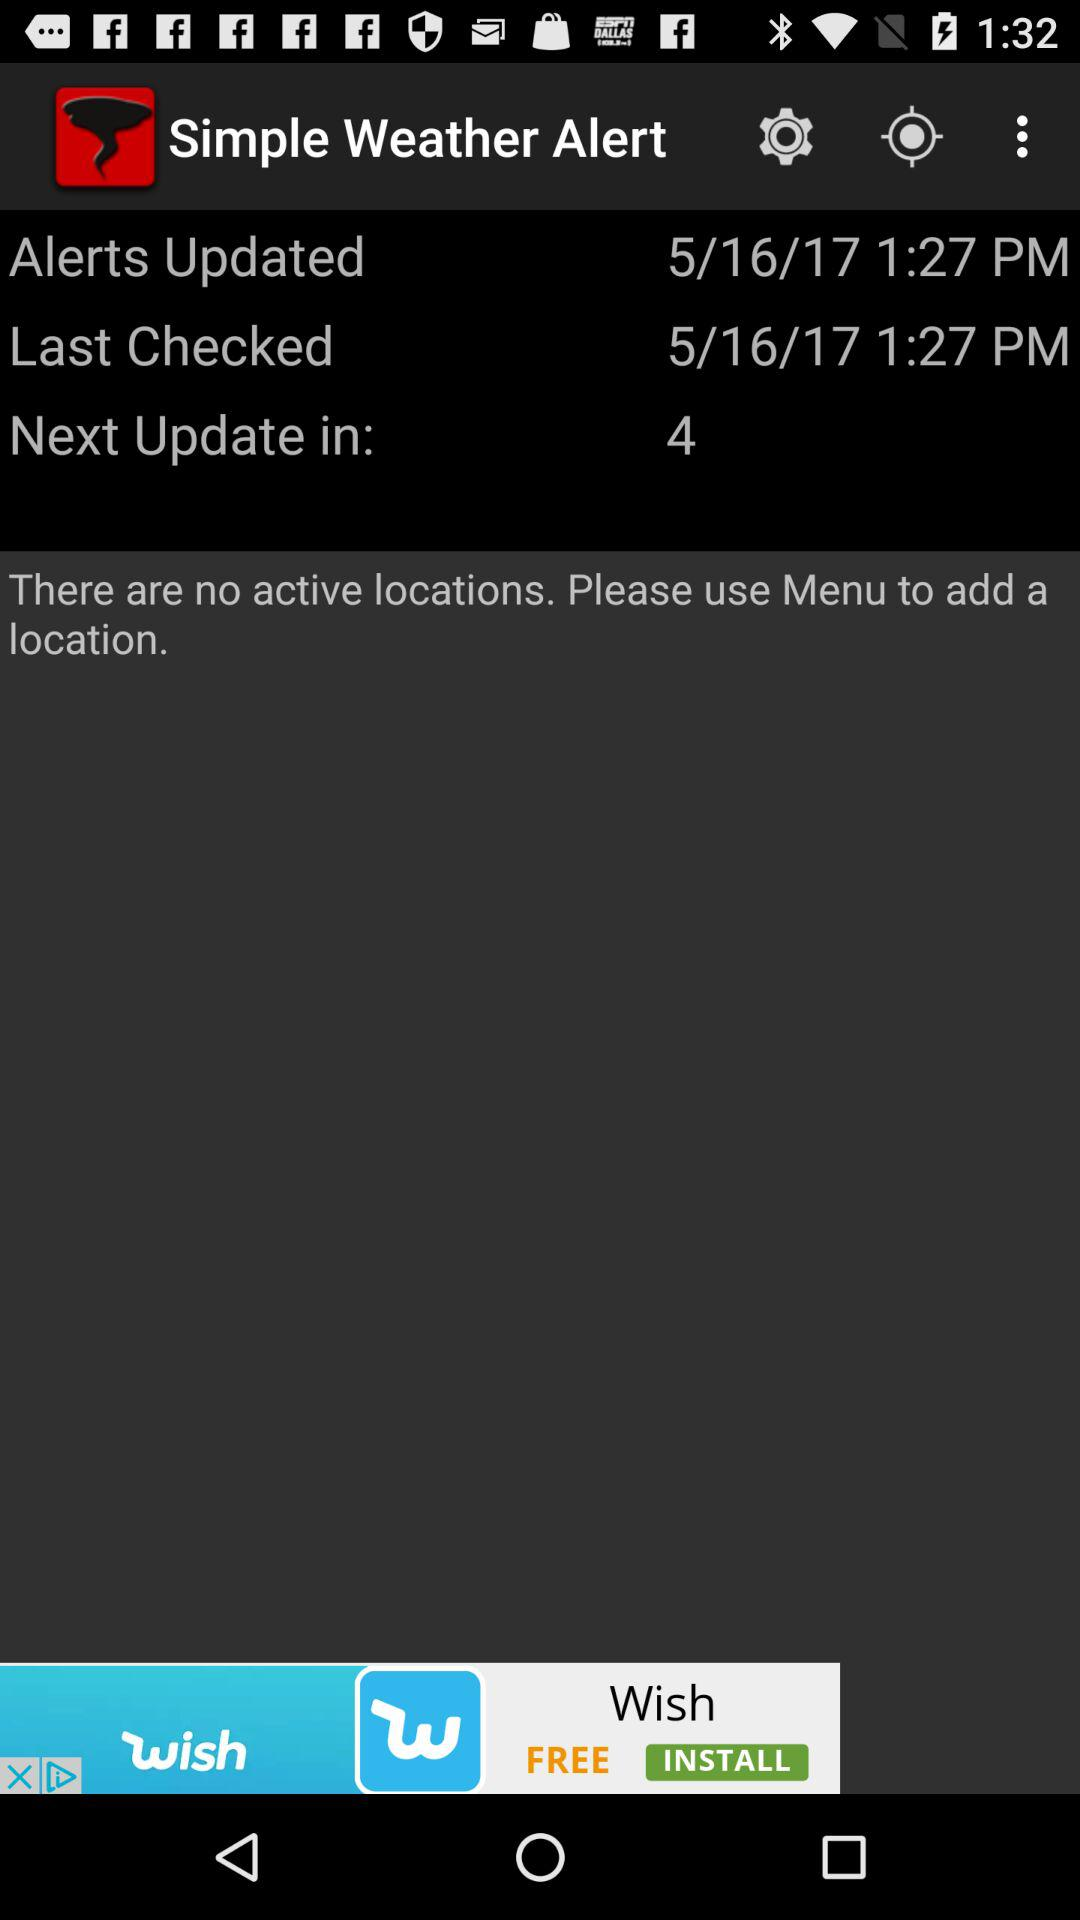When was "Simple Weather Alert" last checked? "Simple Weather Alert" was last checked at 1:27 PM on 5/16/17. 